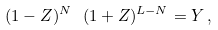<formula> <loc_0><loc_0><loc_500><loc_500>( 1 - Z ) ^ { N } \ ( 1 + Z ) ^ { L - N } = Y \, ,</formula> 